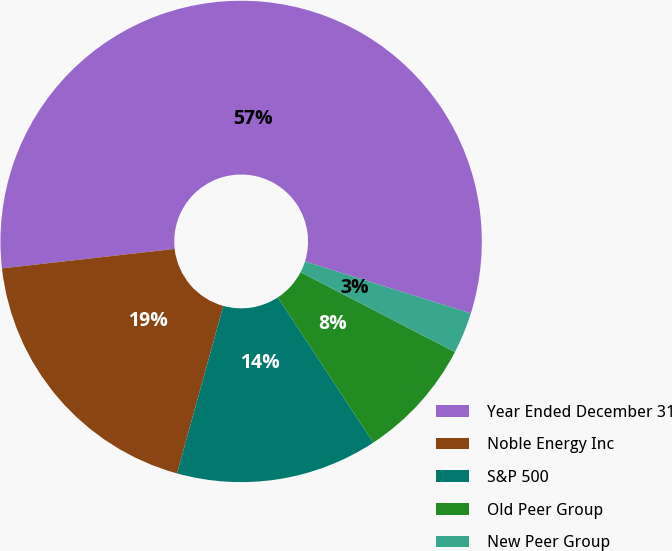Convert chart. <chart><loc_0><loc_0><loc_500><loc_500><pie_chart><fcel>Year Ended December 31<fcel>Noble Energy Inc<fcel>S&P 500<fcel>Old Peer Group<fcel>New Peer Group<nl><fcel>56.62%<fcel>18.92%<fcel>13.54%<fcel>8.15%<fcel>2.77%<nl></chart> 